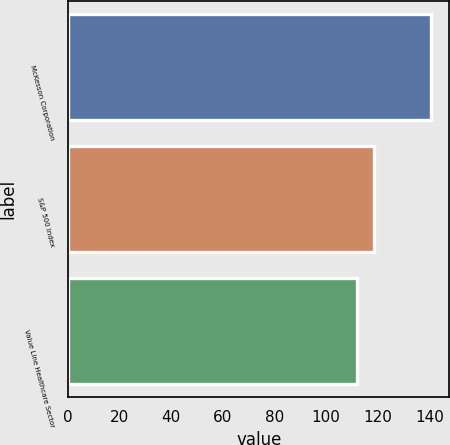Convert chart. <chart><loc_0><loc_0><loc_500><loc_500><bar_chart><fcel>McKesson Corporation<fcel>S&P 500 Index<fcel>Value Line Healthcare Sector<nl><fcel>140.65<fcel>118.6<fcel>111.76<nl></chart> 